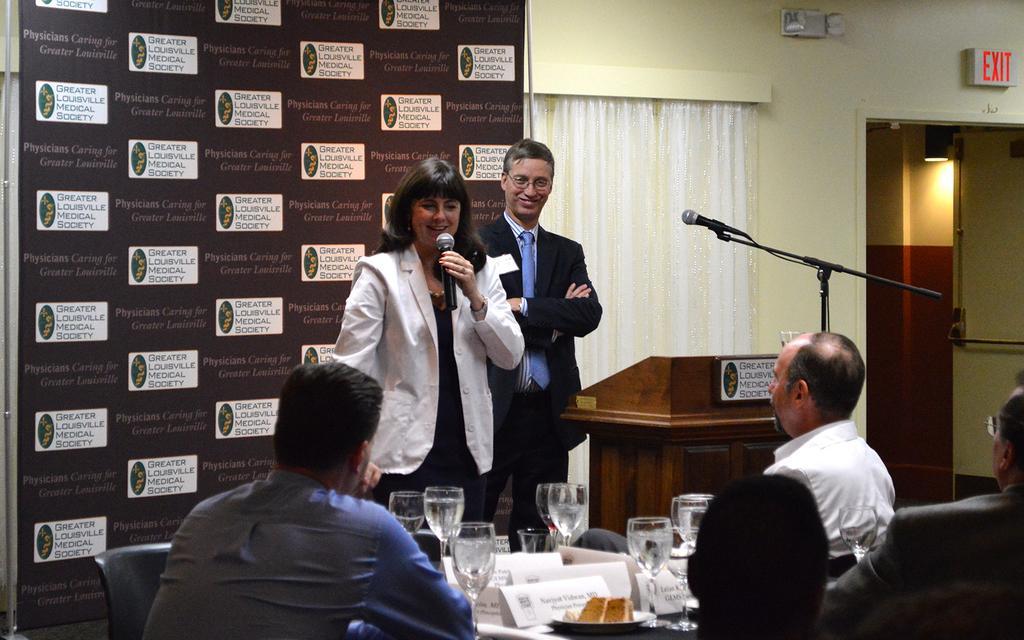Can you describe this image briefly? In this image we can see some persons sitting on chairs paying attention to the persons who are standing at the background of the image holding microphone in their hands there is wooden block on which there is microphone, there is curtain and door and at the foreground of the image there are some glasses and name boards on table. 